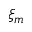Convert formula to latex. <formula><loc_0><loc_0><loc_500><loc_500>\xi _ { m }</formula> 